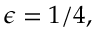<formula> <loc_0><loc_0><loc_500><loc_500>\epsilon = 1 / 4 ,</formula> 